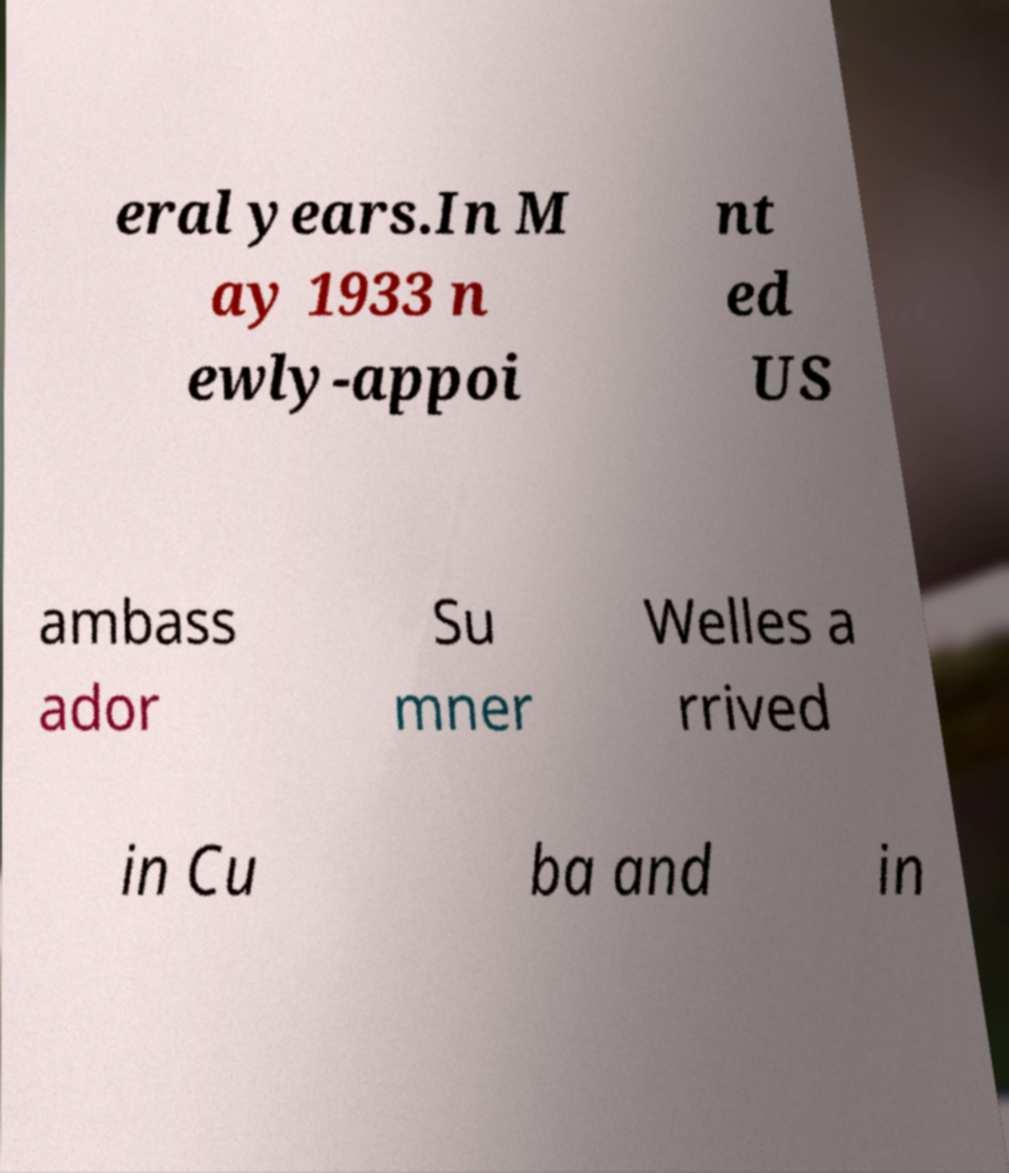For documentation purposes, I need the text within this image transcribed. Could you provide that? eral years.In M ay 1933 n ewly-appoi nt ed US ambass ador Su mner Welles a rrived in Cu ba and in 